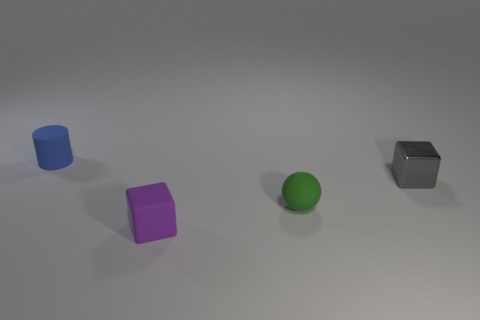Add 1 small blue rubber objects. How many objects exist? 5 Subtract all purple cubes. How many cubes are left? 1 Subtract all cylinders. How many objects are left? 3 Subtract 1 blocks. How many blocks are left? 1 Subtract all blue balls. Subtract all yellow cylinders. How many balls are left? 1 Subtract all cyan metallic cubes. Subtract all purple cubes. How many objects are left? 3 Add 2 metal blocks. How many metal blocks are left? 3 Add 1 purple balls. How many purple balls exist? 1 Subtract 0 purple cylinders. How many objects are left? 4 